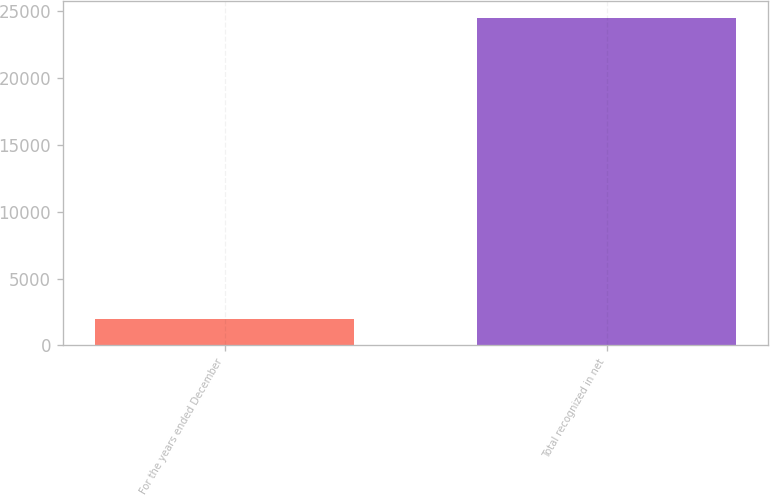Convert chart to OTSL. <chart><loc_0><loc_0><loc_500><loc_500><bar_chart><fcel>For the years ended December<fcel>Total recognized in net<nl><fcel>2005<fcel>24534<nl></chart> 